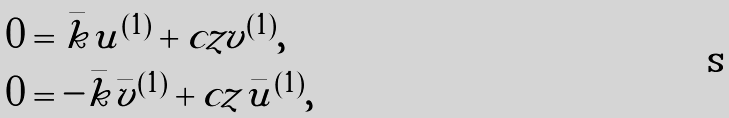<formula> <loc_0><loc_0><loc_500><loc_500>& 0 = \bar { k } u ^ { ( 1 ) } + c z v ^ { ( 1 ) } , \\ & 0 = - \bar { k } \bar { v } ^ { ( 1 ) } + c z \bar { u } ^ { ( 1 ) } ,</formula> 